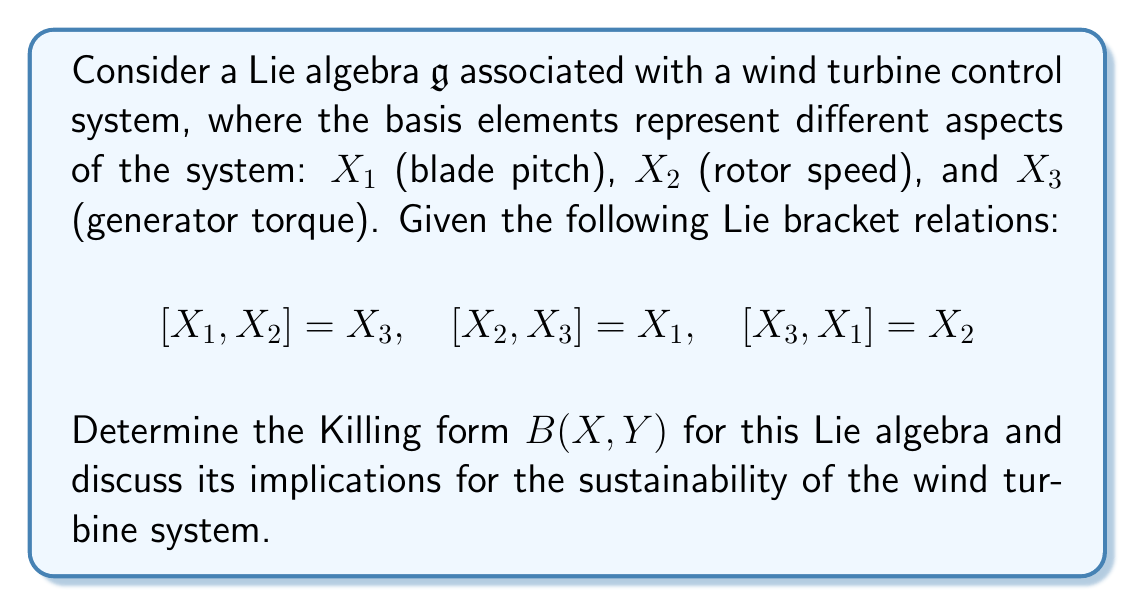Could you help me with this problem? To find the Killing form of the given Lie algebra, we follow these steps:

1) The Killing form is defined as $B(X,Y) = \text{tr}(\text{ad}_X \circ \text{ad}_Y)$, where $\text{ad}_X$ is the adjoint representation of $X$.

2) First, we need to find the matrix representations of $\text{ad}_{X_1}$, $\text{ad}_{X_2}$, and $\text{ad}_{X_3}$:

   $\text{ad}_{X_1} = \begin{pmatrix} 0 & 0 & -1 \\ 0 & 0 & 0 \\ 1 & 0 & 0 \end{pmatrix}$

   $\text{ad}_{X_2} = \begin{pmatrix} 0 & 0 & 0 \\ 0 & 0 & -1 \\ -1 & 1 & 0 \end{pmatrix}$

   $\text{ad}_{X_3} = \begin{pmatrix} 0 & 1 & 0 \\ -1 & 0 & 0 \\ 0 & 1 & 0 \end{pmatrix}$

3) Now, we calculate $B(X_i,X_j)$ for all pairs $i,j \in \{1,2,3\}$:

   $B(X_1,X_1) = \text{tr}(\text{ad}_{X_1} \circ \text{ad}_{X_1}) = -2$
   $B(X_2,X_2) = \text{tr}(\text{ad}_{X_2} \circ \text{ad}_{X_2}) = -2$
   $B(X_3,X_3) = \text{tr}(\text{ad}_{X_3} \circ \text{ad}_{X_3}) = -2$
   $B(X_1,X_2) = B(X_2,X_1) = \text{tr}(\text{ad}_{X_1} \circ \text{ad}_{X_2}) = 0$
   $B(X_1,X_3) = B(X_3,X_1) = \text{tr}(\text{ad}_{X_1} \circ \text{ad}_{X_3}) = 0$
   $B(X_2,X_3) = B(X_3,X_2) = \text{tr}(\text{ad}_{X_2} \circ \text{ad}_{X_3}) = 0$

4) Therefore, the Killing form can be represented as a matrix:

   $B = \begin{pmatrix} -2 & 0 & 0 \\ 0 & -2 & 0 \\ 0 & 0 & -2 \end{pmatrix}$

5) Implications for sustainability:
   - The Killing form is non-degenerate (det(B) ≠ 0), indicating that the Lie algebra is semisimple. This suggests that the control system has a robust structure, which is beneficial for the long-term stability and sustainability of the wind turbine.
   - The diagonal nature of the Killing form implies that the three components (blade pitch, rotor speed, and generator torque) are orthogonal to each other in the Lie algebra. This orthogonality can lead to more efficient control and easier optimization of the wind turbine system, potentially improving its overall sustainability.
   - The negative values on the diagonal indicate that the Lie algebra is compact, which often corresponds to conservation laws in physical systems. This could imply that the wind turbine system has inherent energy conservation properties, aligning well with sustainability goals.
Answer: The Killing form for the given Lie algebra is:

$$B = \begin{pmatrix} -2 & 0 & 0 \\ 0 & -2 & 0 \\ 0 & 0 & -2 \end{pmatrix}$$

This non-degenerate, diagonal, negative-definite Killing form indicates a semisimple, compact Lie algebra, suggesting a robust and potentially energy-conserving control system for the wind turbine, which aligns well with sustainability goals. 